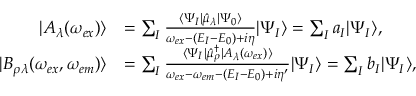Convert formula to latex. <formula><loc_0><loc_0><loc_500><loc_500>\begin{array} { r l } { | A _ { \lambda } ( \omega _ { e x } ) \rangle } & { = \sum _ { I } \frac { \langle \Psi _ { I } | \hat { \mu } _ { \lambda } | \Psi _ { 0 } \rangle } { \omega _ { e x } - ( E _ { I } - E _ { 0 } ) + i \eta } | \Psi _ { I } \rangle = \sum _ { I } a _ { I } | \Psi _ { I } \rangle , } \\ { | B _ { \rho \lambda } ( \omega _ { e x } , \omega _ { e m } ) \rangle } & { = \sum _ { I } \frac { \langle \Psi _ { I } | \hat { \mu } _ { \rho } ^ { \dagger } | A _ { \lambda } ( \omega _ { e x } ) \rangle } { \omega _ { e x } - \omega _ { e m } - ( E _ { I } - E _ { 0 } ) + i \eta ^ { \prime } } | \Psi _ { I } \rangle = \sum _ { I } b _ { I } | \Psi _ { I } \rangle , } \end{array}</formula> 